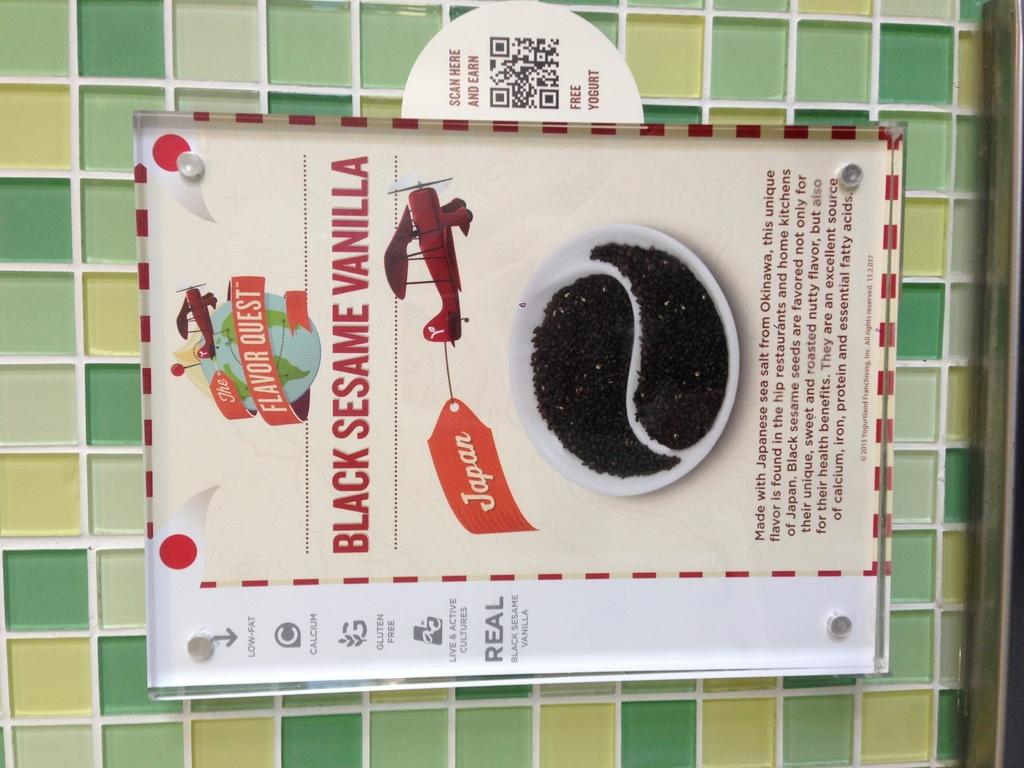<image>
Provide a brief description of the given image. A professional advertisement for Black Sesame Vanilla coffee hangs on a tiled wall. 